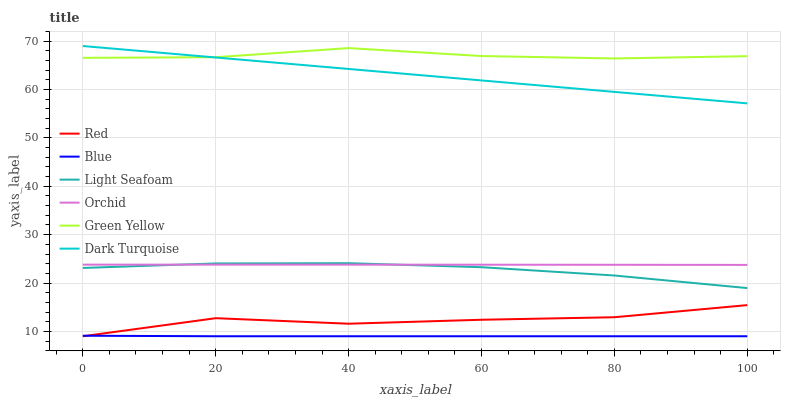Does Light Seafoam have the minimum area under the curve?
Answer yes or no. No. Does Light Seafoam have the maximum area under the curve?
Answer yes or no. No. Is Light Seafoam the smoothest?
Answer yes or no. No. Is Light Seafoam the roughest?
Answer yes or no. No. Does Light Seafoam have the lowest value?
Answer yes or no. No. Does Light Seafoam have the highest value?
Answer yes or no. No. Is Blue less than Light Seafoam?
Answer yes or no. Yes. Is Green Yellow greater than Red?
Answer yes or no. Yes. Does Blue intersect Light Seafoam?
Answer yes or no. No. 